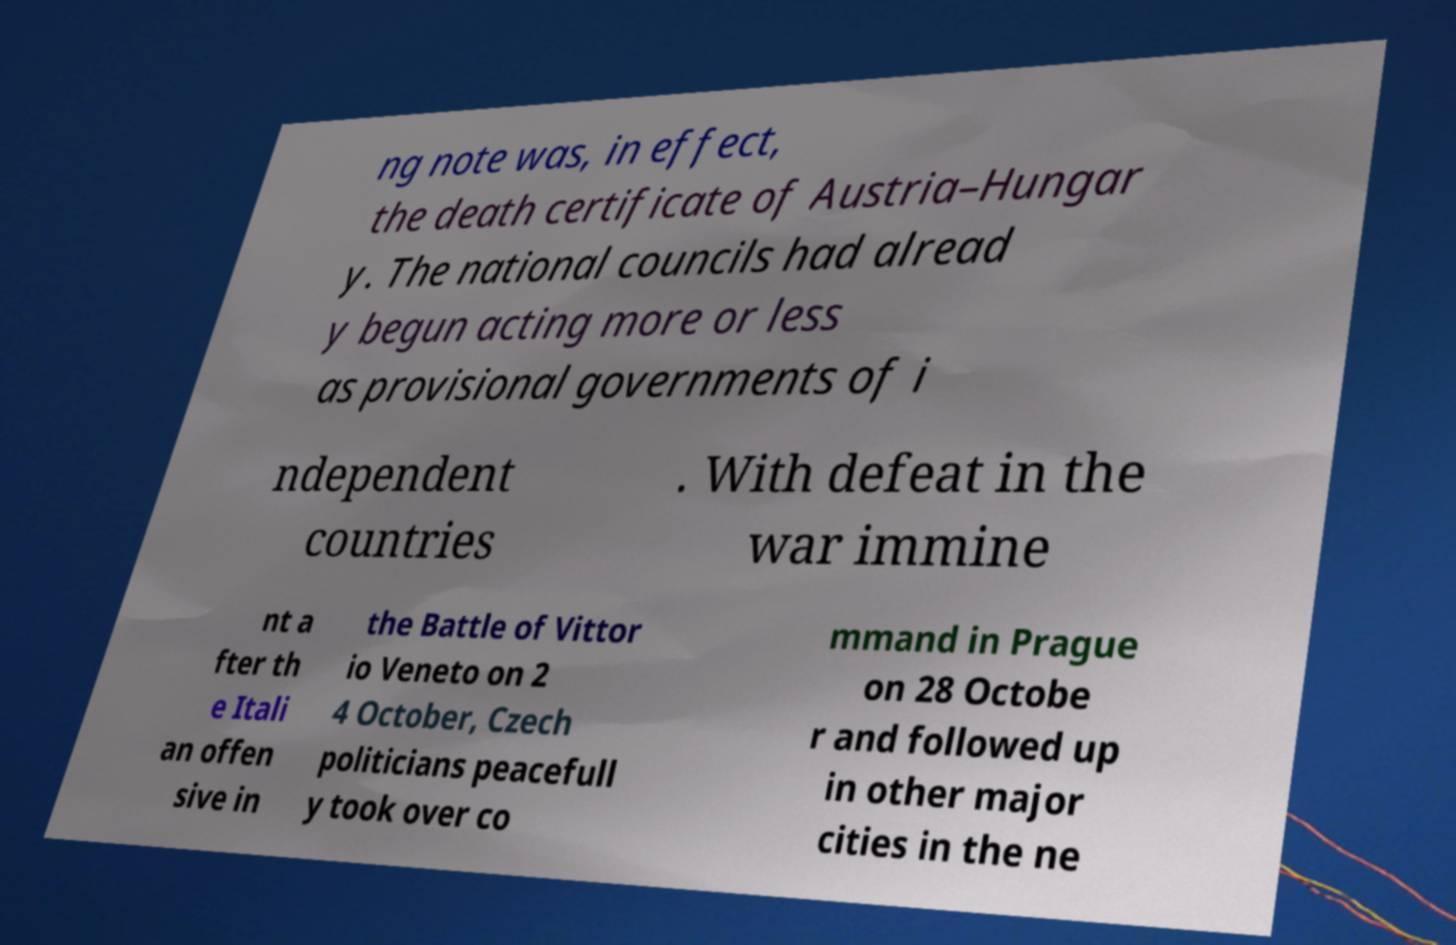There's text embedded in this image that I need extracted. Can you transcribe it verbatim? ng note was, in effect, the death certificate of Austria–Hungar y. The national councils had alread y begun acting more or less as provisional governments of i ndependent countries . With defeat in the war immine nt a fter th e Itali an offen sive in the Battle of Vittor io Veneto on 2 4 October, Czech politicians peacefull y took over co mmand in Prague on 28 Octobe r and followed up in other major cities in the ne 